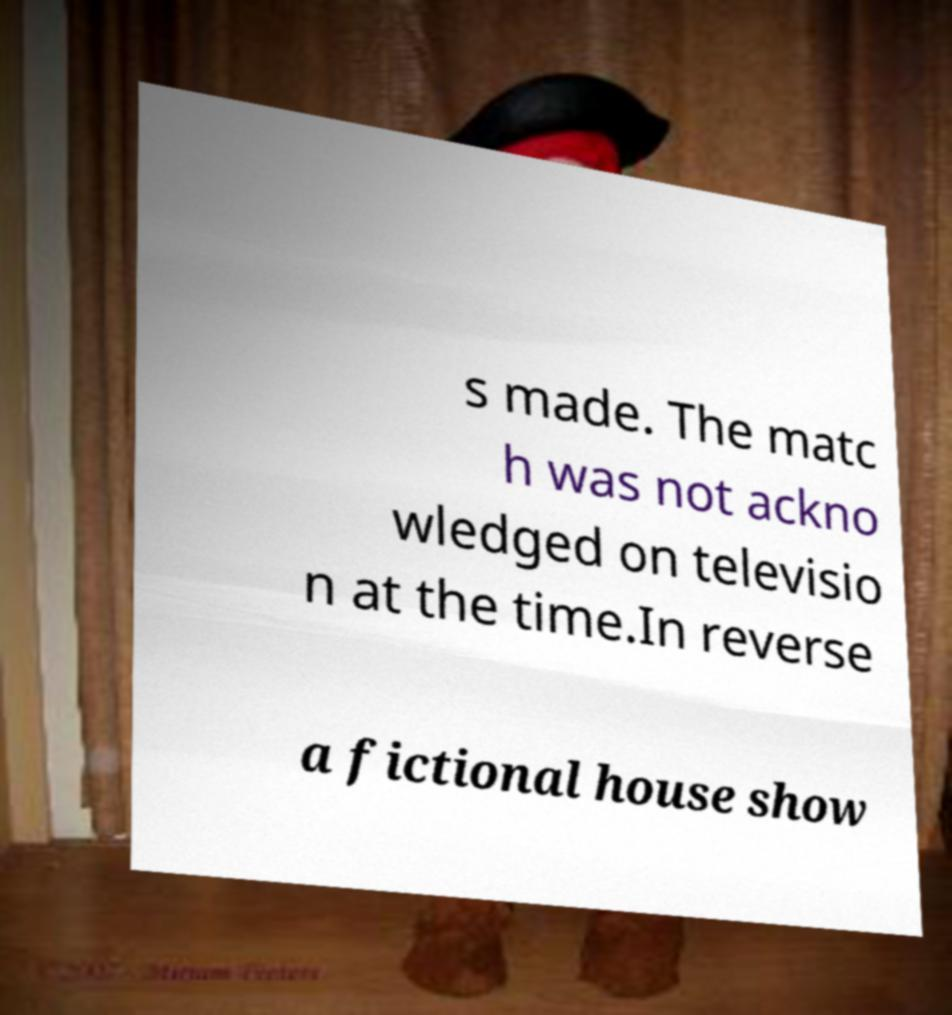Could you extract and type out the text from this image? s made. The matc h was not ackno wledged on televisio n at the time.In reverse a fictional house show 